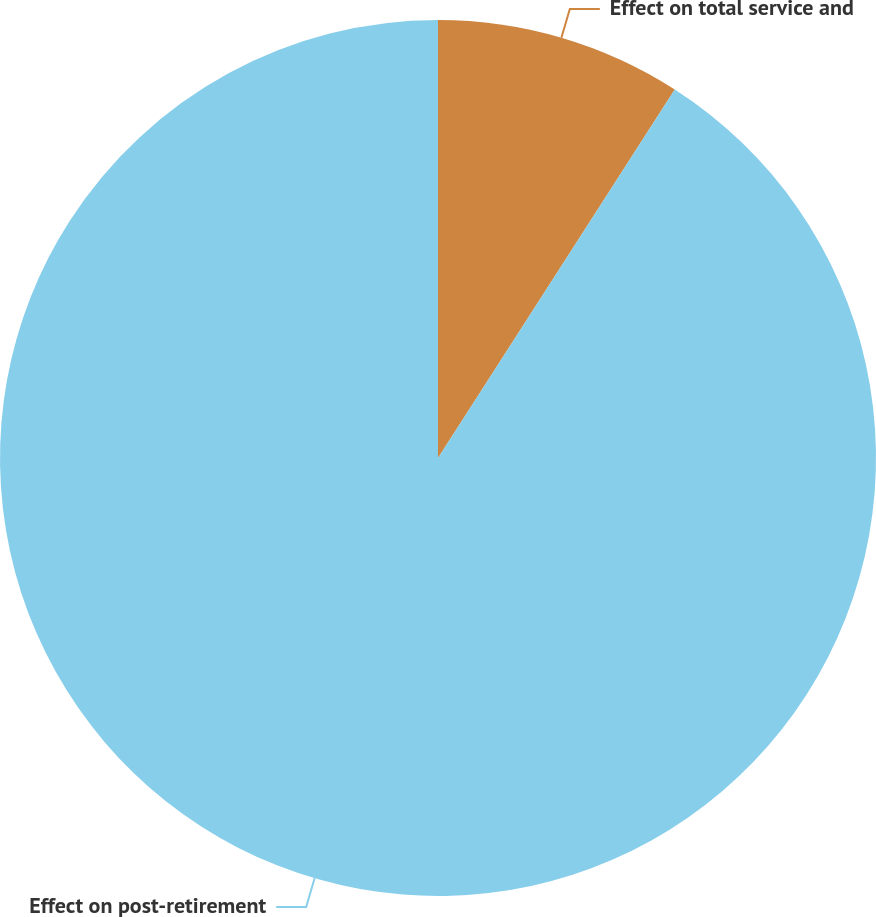<chart> <loc_0><loc_0><loc_500><loc_500><pie_chart><fcel>Effect on total service and<fcel>Effect on post-retirement<nl><fcel>9.09%<fcel>90.91%<nl></chart> 